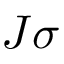Convert formula to latex. <formula><loc_0><loc_0><loc_500><loc_500>J { \sigma }</formula> 